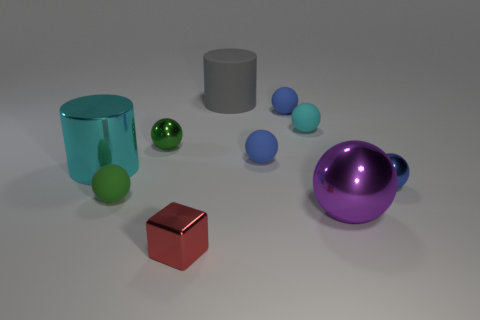Subtract all blue balls. How many were subtracted if there are1blue balls left? 2 Subtract all cyan cylinders. How many blue spheres are left? 3 Subtract all big spheres. How many spheres are left? 6 Subtract 2 balls. How many balls are left? 5 Subtract all cyan balls. How many balls are left? 6 Subtract all blue balls. Subtract all cyan cylinders. How many balls are left? 4 Subtract all cylinders. How many objects are left? 8 Add 6 small green matte things. How many small green matte things exist? 7 Subtract 0 purple blocks. How many objects are left? 10 Subtract all small purple metallic balls. Subtract all cyan matte objects. How many objects are left? 9 